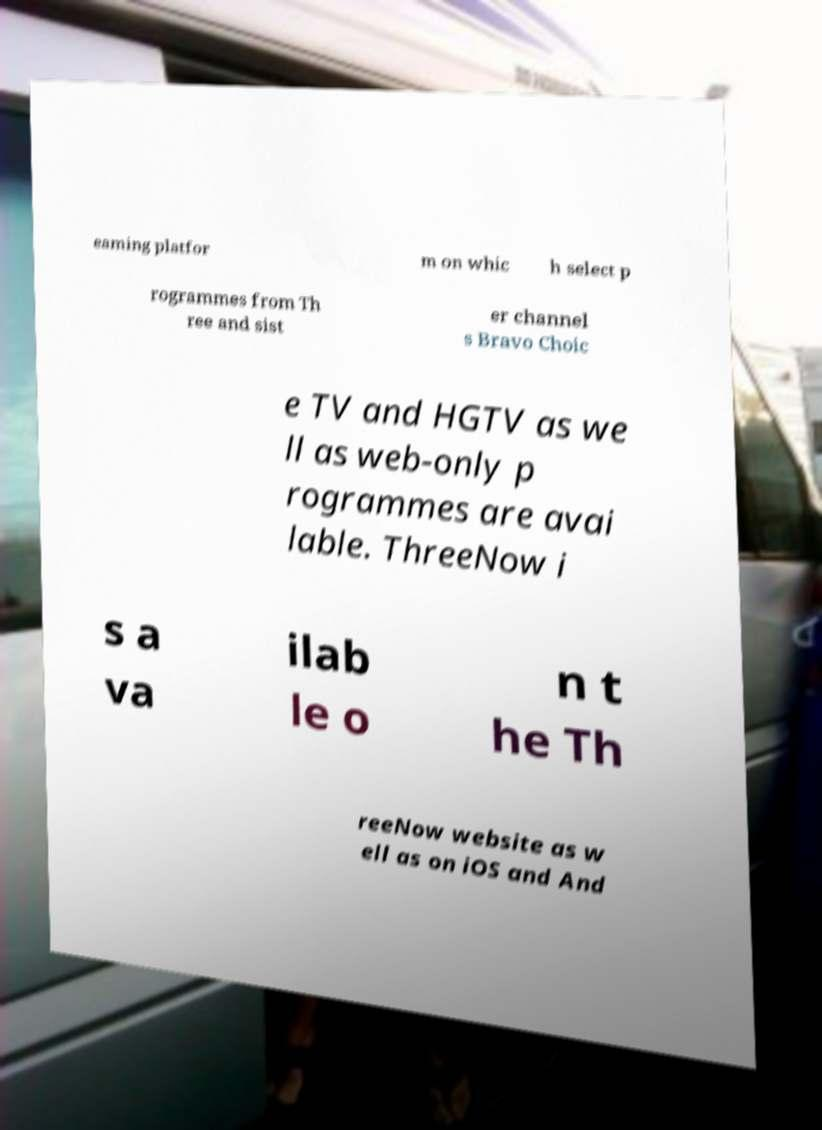Can you read and provide the text displayed in the image?This photo seems to have some interesting text. Can you extract and type it out for me? eaming platfor m on whic h select p rogrammes from Th ree and sist er channel s Bravo Choic e TV and HGTV as we ll as web-only p rogrammes are avai lable. ThreeNow i s a va ilab le o n t he Th reeNow website as w ell as on iOS and And 